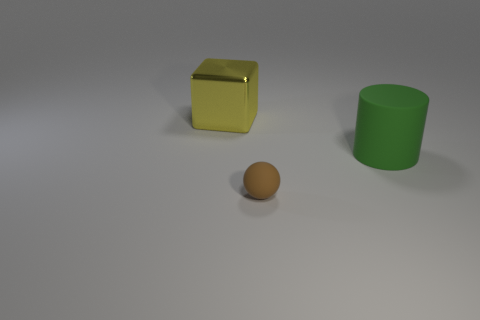Add 1 large yellow blocks. How many objects exist? 4 Subtract all blocks. How many objects are left? 2 Subtract all cyan cylinders. Subtract all large cubes. How many objects are left? 2 Add 3 large objects. How many large objects are left? 5 Add 2 big green matte things. How many big green matte things exist? 3 Subtract 0 cyan balls. How many objects are left? 3 